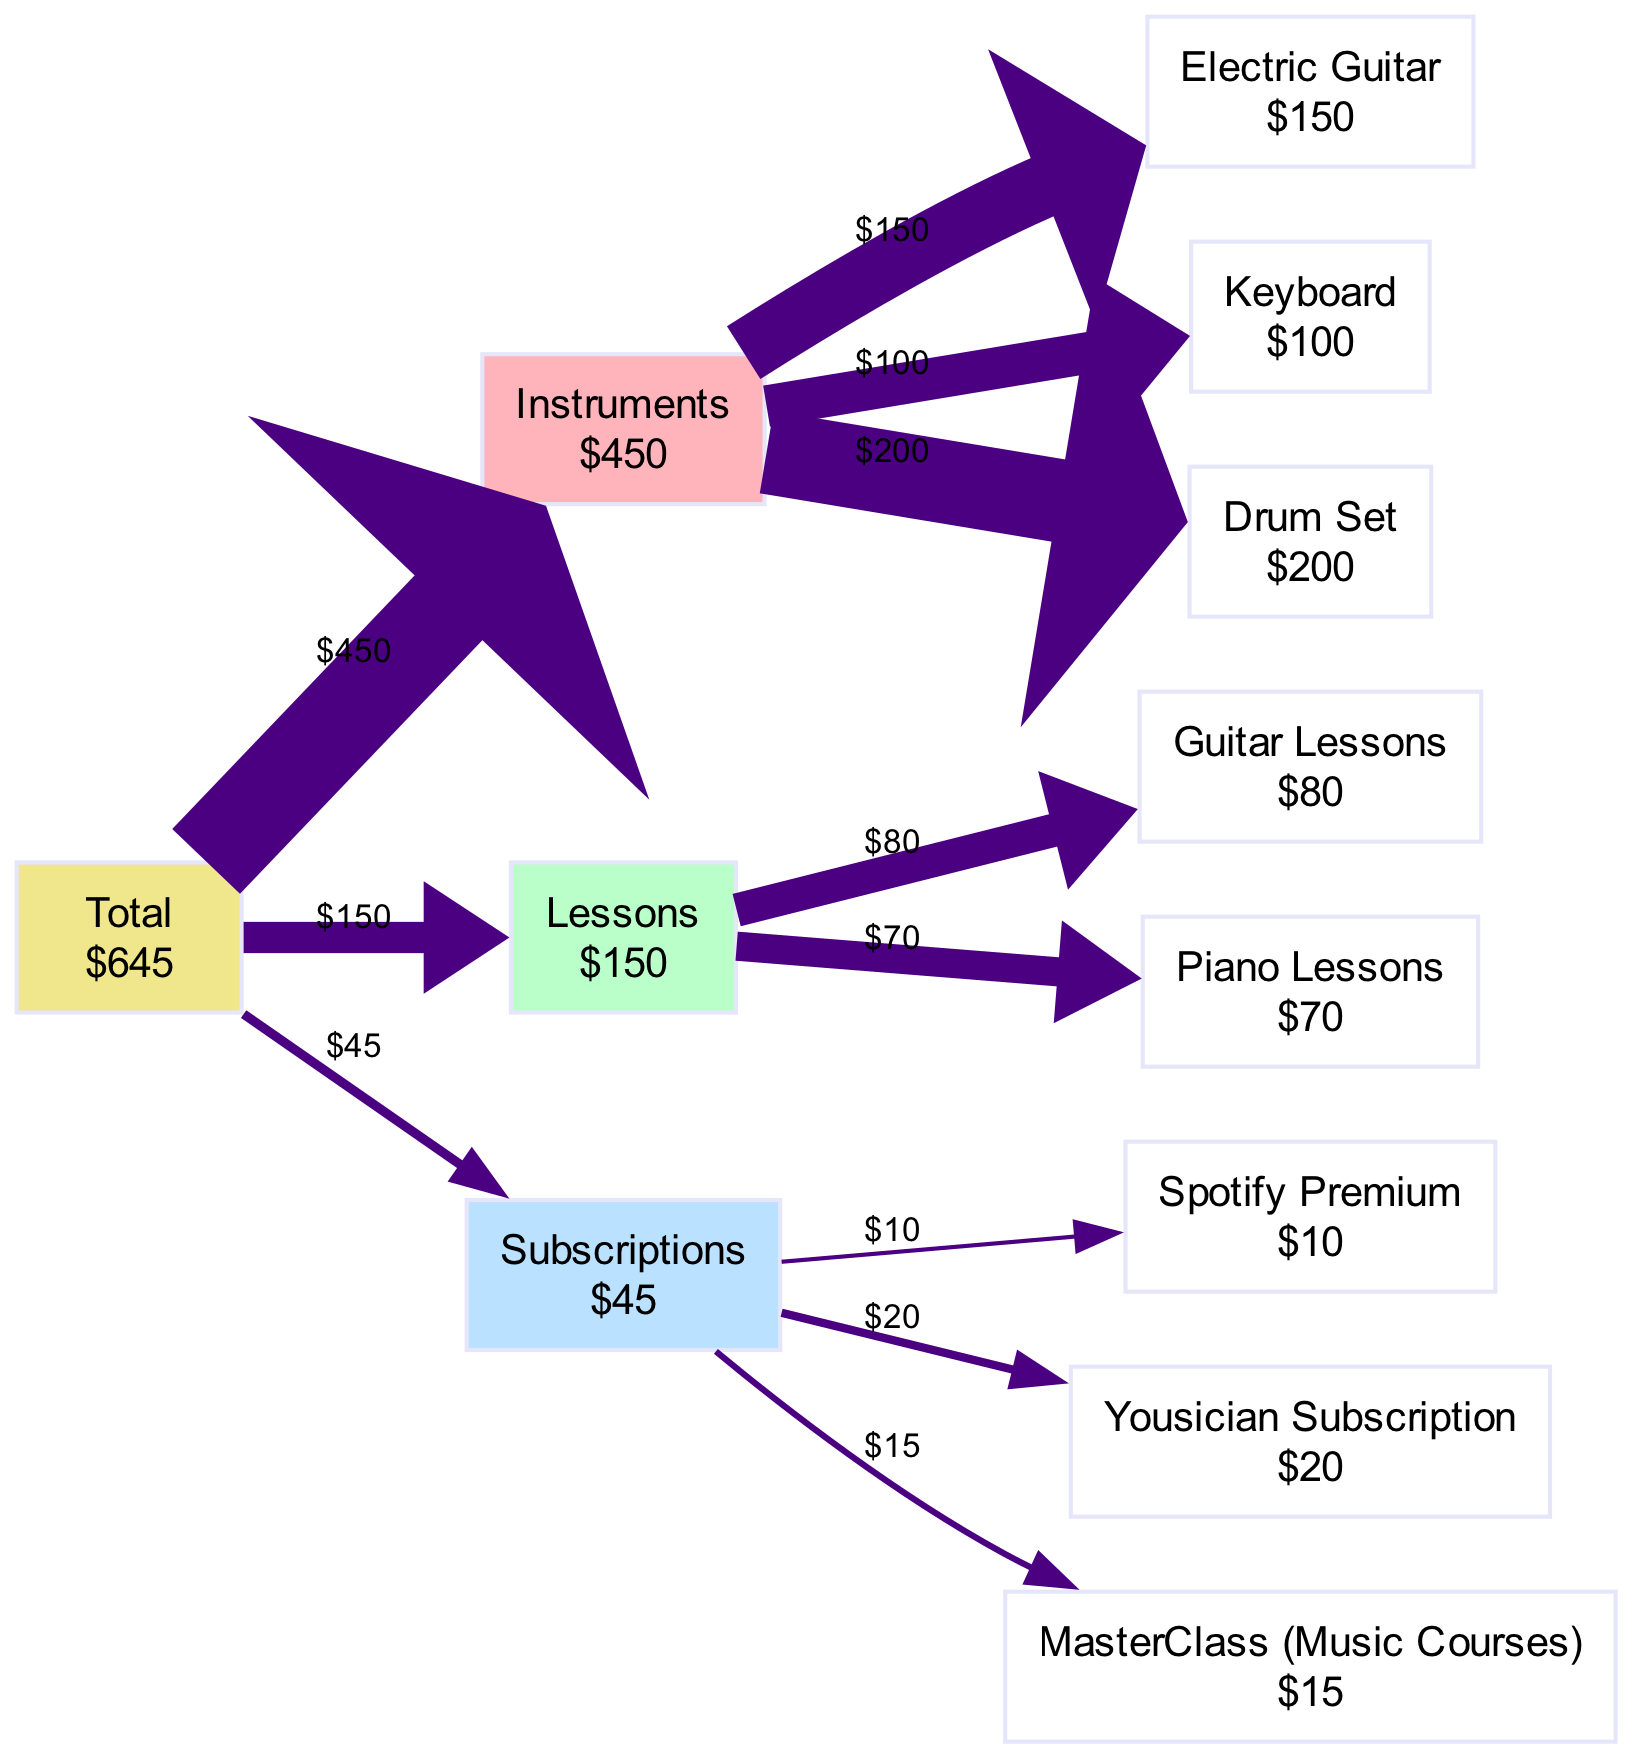What is the total monthly expenditure on music? The total monthly expenditure is calculated by summing all the costs listed in the diagram. The costs are: Electric Guitar ($150), Keyboard ($100), Drum Set ($200), Guitar Lessons ($80), Piano Lessons ($70), Spotify Premium ($10), Yousician Subscription ($20), and MasterClass (Music Courses) ($15). Adding these gives a total of $645.
Answer: 645 Which category has the highest expenditure? To determine the category with the highest expenditure, we look at the totals for each category: Instruments ($450), Lessons ($150), and Subscriptions ($45). The Instruments category has the highest total of $450.
Answer: Instruments How much did the Drum Set cost? The cost of the Drum Set is directly mentioned as an item under the Instruments category, listed with the cost of $200.
Answer: 200 What percentage of the total expenditure is spent on Lessons? First, we find the total expenditure, which is $645. The expenditures on Lessons amount to $150. We calculate the percentage by dividing the Lessons total by the overall total and multiplying by 100: (150/645)*100, which is approximately 23.26%.
Answer: 23.26 percent How many items are listed under the Subscriptions category? The Subscriptions category lists three items: Spotify Premium, Yousician Subscription, and MasterClass (Music Courses). Thus, we count these items for our answer.
Answer: 3 What do the edges represent in the diagram? The edges in the Sankey Diagram represent the flow of money from the Total expenditure node to each category and then to the individual items, showing how much is assigned to each area of expenditure.
Answer: Flow of money Which instrument has the lowest individual cost? By examining the costs of the instruments: Electric Guitar ($150), Keyboard ($100), Drum Set ($200), the Keyboard has the lowest cost among these items.
Answer: Keyboard What is the total cost for Guitar Lessons and Piano Lessons combined? The cost for Guitar Lessons is $80 and for Piano Lessons is $70. We add these two amounts together: $80 + $70 = $150.
Answer: 150 What color represents the Lessons category in the diagram? The different categories are represented by distinct colors. The diagram assigns the color #BAFFC9 to the Lessons category.
Answer: #BAFFC9 